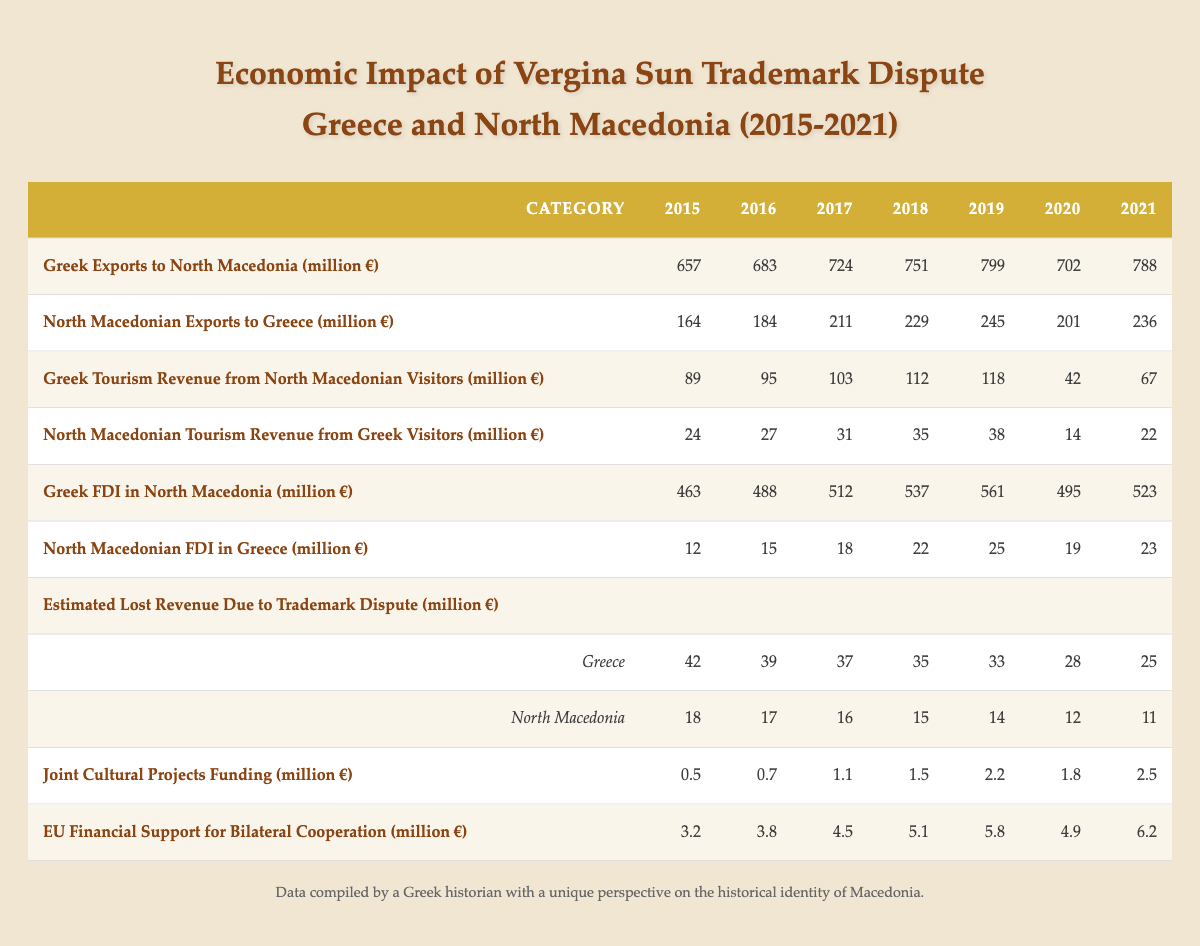What was the total Greek FDI in North Macedonia from 2015 to 2021? To find the total Greek FDI from 2015 to 2021, I will sum the values from each year: 463 + 488 + 512 + 537 + 561 + 495 + 523 = 3079 million euros.
Answer: 3079 million euros What was the highest value of North Macedonian exports to Greece during the period? By examining the table, the highest value for North Macedonian exports to Greece is in 2019, which is 245 million euros.
Answer: 245 million euros Did the estimated lost revenue for Greece due to the trademark dispute decrease from 2015 to 2021? By checking the values in the table for Greece, I see that the estimated lost revenue decreased each year: from 42 million euros in 2015 to 25 million euros in 2021. Therefore, the answer is yes.
Answer: Yes What was the average Greek tourism revenue from North Macedonian visitors over the years? The tourism revenue figures for Greece over the years are: 89, 95, 103, 112, 118, 42, 67. I will sum these values to get 626 million euros and divide by 7 to find the average: 626 / 7 = 89.43 million euros.
Answer: Approximately 89.43 million euros In which year did North Macedonia see the lowest FDI in Greece? Examining the values for North Macedonian FDI in Greece from the table, the lowest value is in 2015, which is 12 million euros.
Answer: 12 million euros What was the difference between joint cultural projects funding in 2019 and 2020? I will find the values for joint cultural projects funding in 2019 (2.2 million euros) and 2020 (1.8 million euros), and then calculate the difference: 2.2 - 1.8 = 0.4 million euros.
Answer: 0.4 million euros Was there an increase in EU financial support for bilateral cooperation from 2015 to 2021? Looking at the table, I can see that EU financial support increased from 3.2 million euros in 2015 to 6.2 million euros in 2021. Thus, the answer is yes.
Answer: Yes What is the total estimated lost revenue for North Macedonia due to the trademark dispute from 2015 to 2021? To find the total for North Macedonia, I will sum the values for each year: 18 + 17 + 16 + 15 + 14 + 12 + 11 = 103 million euros.
Answer: 103 million euros In what year did Greek exports to North Macedonia reach 799 million euros? By reviewing the table, I can see that Greek exports to North Macedonia reached 799 million euros in 2019.
Answer: 2019 